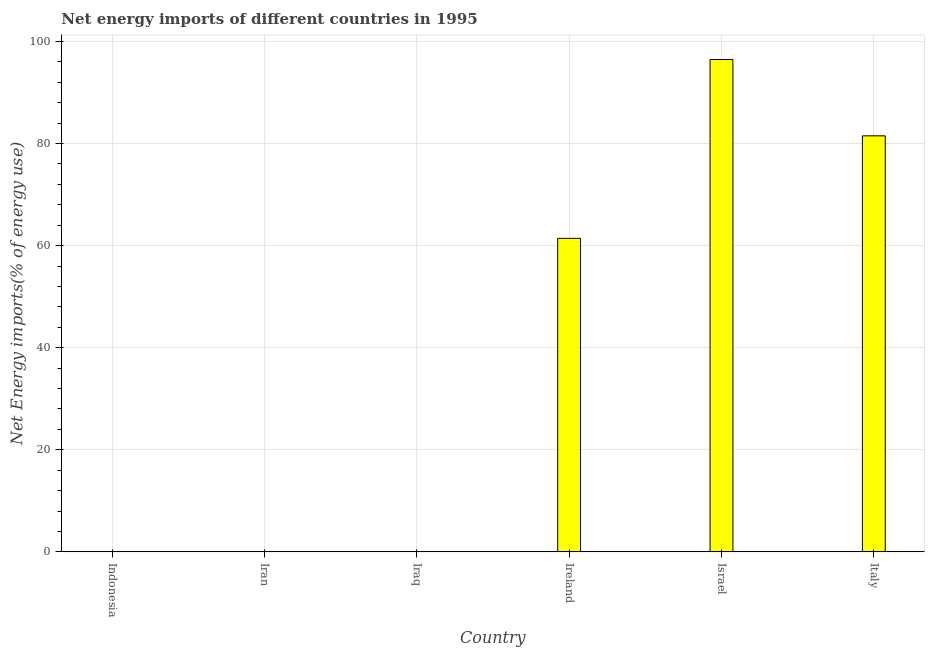Does the graph contain any zero values?
Offer a very short reply. Yes. Does the graph contain grids?
Your answer should be compact. Yes. What is the title of the graph?
Keep it short and to the point. Net energy imports of different countries in 1995. What is the label or title of the Y-axis?
Give a very brief answer. Net Energy imports(% of energy use). Across all countries, what is the maximum energy imports?
Provide a short and direct response. 96.47. Across all countries, what is the minimum energy imports?
Give a very brief answer. 0. What is the sum of the energy imports?
Keep it short and to the point. 239.41. What is the difference between the energy imports in Israel and Italy?
Keep it short and to the point. 14.96. What is the average energy imports per country?
Your answer should be compact. 39.9. What is the median energy imports?
Make the answer very short. 30.71. In how many countries, is the energy imports greater than 40 %?
Offer a terse response. 3. Is the difference between the energy imports in Israel and Italy greater than the difference between any two countries?
Your response must be concise. No. What is the difference between the highest and the second highest energy imports?
Ensure brevity in your answer.  14.96. Is the sum of the energy imports in Ireland and Italy greater than the maximum energy imports across all countries?
Offer a very short reply. Yes. What is the difference between the highest and the lowest energy imports?
Provide a succinct answer. 96.47. How many bars are there?
Your response must be concise. 3. Are all the bars in the graph horizontal?
Provide a succinct answer. No. What is the Net Energy imports(% of energy use) of Indonesia?
Provide a short and direct response. 0. What is the Net Energy imports(% of energy use) of Ireland?
Your answer should be very brief. 61.43. What is the Net Energy imports(% of energy use) in Israel?
Offer a very short reply. 96.47. What is the Net Energy imports(% of energy use) in Italy?
Ensure brevity in your answer.  81.51. What is the difference between the Net Energy imports(% of energy use) in Ireland and Israel?
Your answer should be very brief. -35.04. What is the difference between the Net Energy imports(% of energy use) in Ireland and Italy?
Provide a short and direct response. -20.09. What is the difference between the Net Energy imports(% of energy use) in Israel and Italy?
Provide a short and direct response. 14.96. What is the ratio of the Net Energy imports(% of energy use) in Ireland to that in Israel?
Your answer should be compact. 0.64. What is the ratio of the Net Energy imports(% of energy use) in Ireland to that in Italy?
Your answer should be compact. 0.75. What is the ratio of the Net Energy imports(% of energy use) in Israel to that in Italy?
Keep it short and to the point. 1.18. 